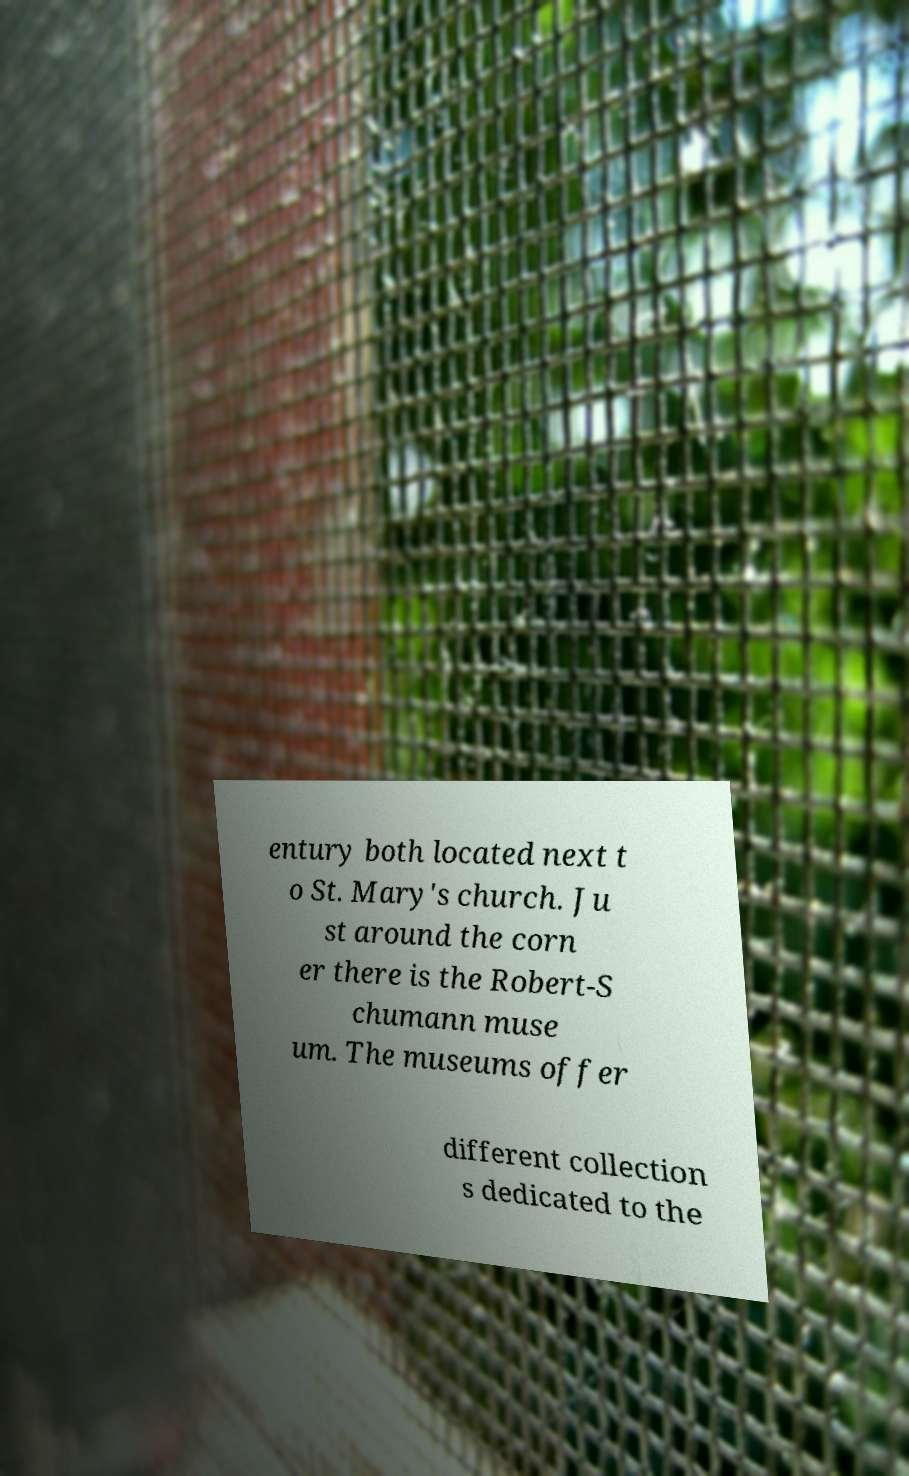Could you assist in decoding the text presented in this image and type it out clearly? entury both located next t o St. Mary's church. Ju st around the corn er there is the Robert-S chumann muse um. The museums offer different collection s dedicated to the 